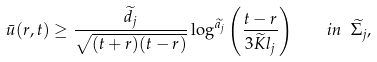Convert formula to latex. <formula><loc_0><loc_0><loc_500><loc_500>\bar { u } ( r , t ) \geq \frac { \widetilde { d _ { j } } } { \sqrt { ( t + r ) ( t - r ) } } \log ^ { \widetilde { a _ { j } } } \left ( \frac { t - r } { 3 \widetilde { K } l _ { j } } \right ) \quad i n \ \widetilde { \Sigma _ { j } } ,</formula> 